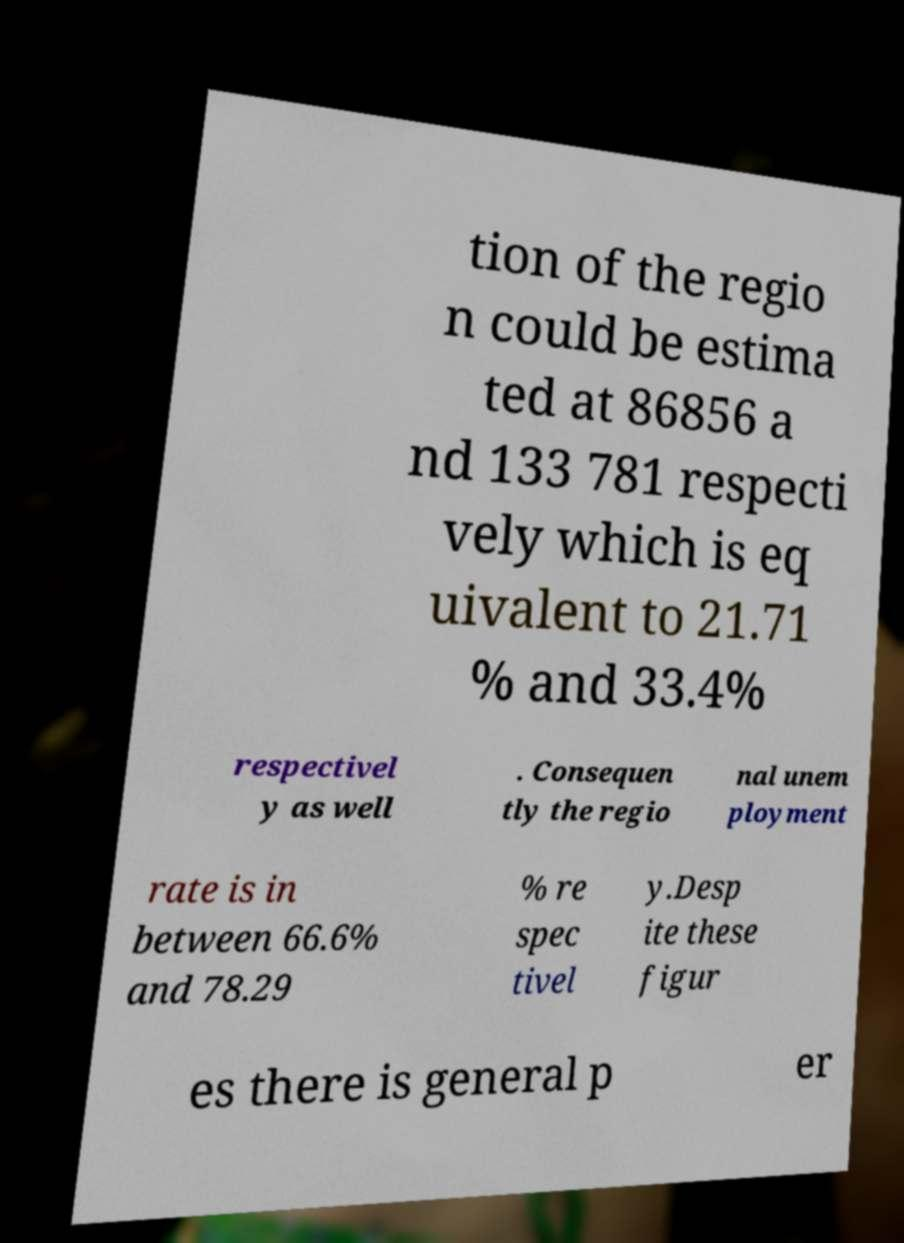Could you extract and type out the text from this image? tion of the regio n could be estima ted at 86856 a nd 133 781 respecti vely which is eq uivalent to 21.71 % and 33.4% respectivel y as well . Consequen tly the regio nal unem ployment rate is in between 66.6% and 78.29 % re spec tivel y.Desp ite these figur es there is general p er 